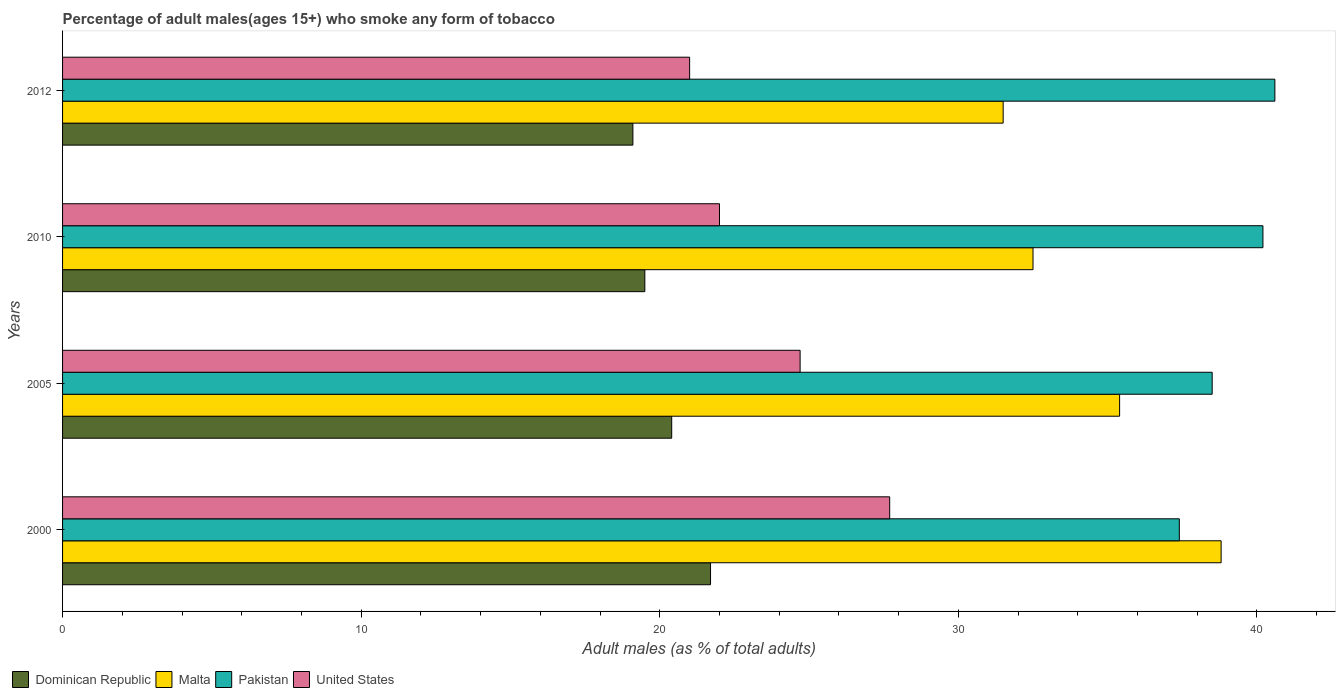How many different coloured bars are there?
Provide a short and direct response. 4. How many groups of bars are there?
Ensure brevity in your answer.  4. Are the number of bars per tick equal to the number of legend labels?
Offer a terse response. Yes. What is the percentage of adult males who smoke in Pakistan in 2012?
Provide a succinct answer. 40.6. Across all years, what is the maximum percentage of adult males who smoke in United States?
Offer a very short reply. 27.7. Across all years, what is the minimum percentage of adult males who smoke in United States?
Your response must be concise. 21. In which year was the percentage of adult males who smoke in Malta maximum?
Make the answer very short. 2000. In which year was the percentage of adult males who smoke in Pakistan minimum?
Offer a terse response. 2000. What is the total percentage of adult males who smoke in United States in the graph?
Offer a terse response. 95.4. What is the difference between the percentage of adult males who smoke in United States in 2000 and that in 2005?
Give a very brief answer. 3. What is the difference between the percentage of adult males who smoke in United States in 2010 and the percentage of adult males who smoke in Malta in 2005?
Your answer should be very brief. -13.4. What is the average percentage of adult males who smoke in Dominican Republic per year?
Make the answer very short. 20.17. In the year 2005, what is the difference between the percentage of adult males who smoke in Malta and percentage of adult males who smoke in Dominican Republic?
Offer a very short reply. 15. What is the ratio of the percentage of adult males who smoke in Dominican Republic in 2000 to that in 2005?
Keep it short and to the point. 1.06. Is the difference between the percentage of adult males who smoke in Malta in 2000 and 2010 greater than the difference between the percentage of adult males who smoke in Dominican Republic in 2000 and 2010?
Give a very brief answer. Yes. What is the difference between the highest and the second highest percentage of adult males who smoke in Malta?
Keep it short and to the point. 3.4. What is the difference between the highest and the lowest percentage of adult males who smoke in Malta?
Give a very brief answer. 7.3. In how many years, is the percentage of adult males who smoke in Malta greater than the average percentage of adult males who smoke in Malta taken over all years?
Provide a succinct answer. 2. Is it the case that in every year, the sum of the percentage of adult males who smoke in United States and percentage of adult males who smoke in Dominican Republic is greater than the sum of percentage of adult males who smoke in Malta and percentage of adult males who smoke in Pakistan?
Ensure brevity in your answer.  No. What does the 3rd bar from the top in 2010 represents?
Make the answer very short. Malta. What does the 4th bar from the bottom in 2010 represents?
Give a very brief answer. United States. How many bars are there?
Give a very brief answer. 16. Are all the bars in the graph horizontal?
Your answer should be very brief. Yes. Are the values on the major ticks of X-axis written in scientific E-notation?
Provide a short and direct response. No. Does the graph contain any zero values?
Your response must be concise. No. Where does the legend appear in the graph?
Offer a terse response. Bottom left. How many legend labels are there?
Make the answer very short. 4. How are the legend labels stacked?
Offer a terse response. Horizontal. What is the title of the graph?
Provide a succinct answer. Percentage of adult males(ages 15+) who smoke any form of tobacco. Does "Mauritius" appear as one of the legend labels in the graph?
Offer a very short reply. No. What is the label or title of the X-axis?
Your answer should be compact. Adult males (as % of total adults). What is the Adult males (as % of total adults) of Dominican Republic in 2000?
Offer a very short reply. 21.7. What is the Adult males (as % of total adults) of Malta in 2000?
Your answer should be very brief. 38.8. What is the Adult males (as % of total adults) in Pakistan in 2000?
Your response must be concise. 37.4. What is the Adult males (as % of total adults) of United States in 2000?
Give a very brief answer. 27.7. What is the Adult males (as % of total adults) of Dominican Republic in 2005?
Offer a very short reply. 20.4. What is the Adult males (as % of total adults) in Malta in 2005?
Offer a terse response. 35.4. What is the Adult males (as % of total adults) in Pakistan in 2005?
Offer a very short reply. 38.5. What is the Adult males (as % of total adults) in United States in 2005?
Keep it short and to the point. 24.7. What is the Adult males (as % of total adults) of Malta in 2010?
Ensure brevity in your answer.  32.5. What is the Adult males (as % of total adults) in Pakistan in 2010?
Offer a very short reply. 40.2. What is the Adult males (as % of total adults) of Dominican Republic in 2012?
Give a very brief answer. 19.1. What is the Adult males (as % of total adults) in Malta in 2012?
Your answer should be very brief. 31.5. What is the Adult males (as % of total adults) of Pakistan in 2012?
Provide a short and direct response. 40.6. What is the Adult males (as % of total adults) of United States in 2012?
Offer a very short reply. 21. Across all years, what is the maximum Adult males (as % of total adults) of Dominican Republic?
Ensure brevity in your answer.  21.7. Across all years, what is the maximum Adult males (as % of total adults) of Malta?
Your response must be concise. 38.8. Across all years, what is the maximum Adult males (as % of total adults) in Pakistan?
Your answer should be compact. 40.6. Across all years, what is the maximum Adult males (as % of total adults) of United States?
Keep it short and to the point. 27.7. Across all years, what is the minimum Adult males (as % of total adults) in Dominican Republic?
Offer a terse response. 19.1. Across all years, what is the minimum Adult males (as % of total adults) of Malta?
Your answer should be compact. 31.5. Across all years, what is the minimum Adult males (as % of total adults) of Pakistan?
Your answer should be very brief. 37.4. Across all years, what is the minimum Adult males (as % of total adults) of United States?
Provide a short and direct response. 21. What is the total Adult males (as % of total adults) of Dominican Republic in the graph?
Your answer should be very brief. 80.7. What is the total Adult males (as % of total adults) in Malta in the graph?
Your answer should be very brief. 138.2. What is the total Adult males (as % of total adults) of Pakistan in the graph?
Your answer should be very brief. 156.7. What is the total Adult males (as % of total adults) of United States in the graph?
Offer a terse response. 95.4. What is the difference between the Adult males (as % of total adults) of Malta in 2000 and that in 2005?
Your answer should be compact. 3.4. What is the difference between the Adult males (as % of total adults) in Pakistan in 2000 and that in 2005?
Give a very brief answer. -1.1. What is the difference between the Adult males (as % of total adults) in United States in 2000 and that in 2005?
Provide a short and direct response. 3. What is the difference between the Adult males (as % of total adults) of Dominican Republic in 2000 and that in 2010?
Your response must be concise. 2.2. What is the difference between the Adult males (as % of total adults) in Malta in 2000 and that in 2010?
Give a very brief answer. 6.3. What is the difference between the Adult males (as % of total adults) of Dominican Republic in 2000 and that in 2012?
Keep it short and to the point. 2.6. What is the difference between the Adult males (as % of total adults) of United States in 2000 and that in 2012?
Your answer should be very brief. 6.7. What is the difference between the Adult males (as % of total adults) in Malta in 2005 and that in 2010?
Provide a succinct answer. 2.9. What is the difference between the Adult males (as % of total adults) in United States in 2005 and that in 2010?
Provide a succinct answer. 2.7. What is the difference between the Adult males (as % of total adults) in Malta in 2010 and that in 2012?
Give a very brief answer. 1. What is the difference between the Adult males (as % of total adults) in Pakistan in 2010 and that in 2012?
Make the answer very short. -0.4. What is the difference between the Adult males (as % of total adults) of Dominican Republic in 2000 and the Adult males (as % of total adults) of Malta in 2005?
Offer a very short reply. -13.7. What is the difference between the Adult males (as % of total adults) in Dominican Republic in 2000 and the Adult males (as % of total adults) in Pakistan in 2005?
Offer a very short reply. -16.8. What is the difference between the Adult males (as % of total adults) in Dominican Republic in 2000 and the Adult males (as % of total adults) in United States in 2005?
Keep it short and to the point. -3. What is the difference between the Adult males (as % of total adults) of Dominican Republic in 2000 and the Adult males (as % of total adults) of Malta in 2010?
Offer a terse response. -10.8. What is the difference between the Adult males (as % of total adults) of Dominican Republic in 2000 and the Adult males (as % of total adults) of Pakistan in 2010?
Offer a very short reply. -18.5. What is the difference between the Adult males (as % of total adults) in Dominican Republic in 2000 and the Adult males (as % of total adults) in United States in 2010?
Offer a very short reply. -0.3. What is the difference between the Adult males (as % of total adults) in Malta in 2000 and the Adult males (as % of total adults) in United States in 2010?
Keep it short and to the point. 16.8. What is the difference between the Adult males (as % of total adults) in Dominican Republic in 2000 and the Adult males (as % of total adults) in Pakistan in 2012?
Keep it short and to the point. -18.9. What is the difference between the Adult males (as % of total adults) of Dominican Republic in 2000 and the Adult males (as % of total adults) of United States in 2012?
Provide a succinct answer. 0.7. What is the difference between the Adult males (as % of total adults) in Malta in 2000 and the Adult males (as % of total adults) in United States in 2012?
Keep it short and to the point. 17.8. What is the difference between the Adult males (as % of total adults) of Dominican Republic in 2005 and the Adult males (as % of total adults) of Malta in 2010?
Your response must be concise. -12.1. What is the difference between the Adult males (as % of total adults) of Dominican Republic in 2005 and the Adult males (as % of total adults) of Pakistan in 2010?
Ensure brevity in your answer.  -19.8. What is the difference between the Adult males (as % of total adults) in Dominican Republic in 2005 and the Adult males (as % of total adults) in United States in 2010?
Give a very brief answer. -1.6. What is the difference between the Adult males (as % of total adults) in Malta in 2005 and the Adult males (as % of total adults) in Pakistan in 2010?
Make the answer very short. -4.8. What is the difference between the Adult males (as % of total adults) in Pakistan in 2005 and the Adult males (as % of total adults) in United States in 2010?
Provide a succinct answer. 16.5. What is the difference between the Adult males (as % of total adults) in Dominican Republic in 2005 and the Adult males (as % of total adults) in Malta in 2012?
Provide a succinct answer. -11.1. What is the difference between the Adult males (as % of total adults) in Dominican Republic in 2005 and the Adult males (as % of total adults) in Pakistan in 2012?
Give a very brief answer. -20.2. What is the difference between the Adult males (as % of total adults) in Malta in 2005 and the Adult males (as % of total adults) in Pakistan in 2012?
Keep it short and to the point. -5.2. What is the difference between the Adult males (as % of total adults) in Malta in 2005 and the Adult males (as % of total adults) in United States in 2012?
Provide a short and direct response. 14.4. What is the difference between the Adult males (as % of total adults) of Pakistan in 2005 and the Adult males (as % of total adults) of United States in 2012?
Ensure brevity in your answer.  17.5. What is the difference between the Adult males (as % of total adults) in Dominican Republic in 2010 and the Adult males (as % of total adults) in Malta in 2012?
Provide a succinct answer. -12. What is the difference between the Adult males (as % of total adults) of Dominican Republic in 2010 and the Adult males (as % of total adults) of Pakistan in 2012?
Your answer should be very brief. -21.1. What is the difference between the Adult males (as % of total adults) of Dominican Republic in 2010 and the Adult males (as % of total adults) of United States in 2012?
Your answer should be compact. -1.5. What is the average Adult males (as % of total adults) of Dominican Republic per year?
Give a very brief answer. 20.18. What is the average Adult males (as % of total adults) in Malta per year?
Ensure brevity in your answer.  34.55. What is the average Adult males (as % of total adults) of Pakistan per year?
Ensure brevity in your answer.  39.17. What is the average Adult males (as % of total adults) of United States per year?
Give a very brief answer. 23.85. In the year 2000, what is the difference between the Adult males (as % of total adults) in Dominican Republic and Adult males (as % of total adults) in Malta?
Your response must be concise. -17.1. In the year 2000, what is the difference between the Adult males (as % of total adults) in Dominican Republic and Adult males (as % of total adults) in Pakistan?
Offer a terse response. -15.7. In the year 2000, what is the difference between the Adult males (as % of total adults) in Malta and Adult males (as % of total adults) in United States?
Your response must be concise. 11.1. In the year 2000, what is the difference between the Adult males (as % of total adults) in Pakistan and Adult males (as % of total adults) in United States?
Your answer should be very brief. 9.7. In the year 2005, what is the difference between the Adult males (as % of total adults) in Dominican Republic and Adult males (as % of total adults) in Pakistan?
Offer a very short reply. -18.1. In the year 2005, what is the difference between the Adult males (as % of total adults) in Malta and Adult males (as % of total adults) in Pakistan?
Make the answer very short. -3.1. In the year 2005, what is the difference between the Adult males (as % of total adults) of Malta and Adult males (as % of total adults) of United States?
Ensure brevity in your answer.  10.7. In the year 2005, what is the difference between the Adult males (as % of total adults) in Pakistan and Adult males (as % of total adults) in United States?
Give a very brief answer. 13.8. In the year 2010, what is the difference between the Adult males (as % of total adults) of Dominican Republic and Adult males (as % of total adults) of Malta?
Give a very brief answer. -13. In the year 2010, what is the difference between the Adult males (as % of total adults) in Dominican Republic and Adult males (as % of total adults) in Pakistan?
Your answer should be compact. -20.7. In the year 2010, what is the difference between the Adult males (as % of total adults) in Malta and Adult males (as % of total adults) in Pakistan?
Make the answer very short. -7.7. In the year 2010, what is the difference between the Adult males (as % of total adults) in Malta and Adult males (as % of total adults) in United States?
Your answer should be compact. 10.5. In the year 2010, what is the difference between the Adult males (as % of total adults) of Pakistan and Adult males (as % of total adults) of United States?
Provide a short and direct response. 18.2. In the year 2012, what is the difference between the Adult males (as % of total adults) in Dominican Republic and Adult males (as % of total adults) in Pakistan?
Your answer should be compact. -21.5. In the year 2012, what is the difference between the Adult males (as % of total adults) of Malta and Adult males (as % of total adults) of Pakistan?
Provide a short and direct response. -9.1. In the year 2012, what is the difference between the Adult males (as % of total adults) in Malta and Adult males (as % of total adults) in United States?
Your answer should be compact. 10.5. In the year 2012, what is the difference between the Adult males (as % of total adults) in Pakistan and Adult males (as % of total adults) in United States?
Provide a succinct answer. 19.6. What is the ratio of the Adult males (as % of total adults) in Dominican Republic in 2000 to that in 2005?
Provide a succinct answer. 1.06. What is the ratio of the Adult males (as % of total adults) in Malta in 2000 to that in 2005?
Keep it short and to the point. 1.1. What is the ratio of the Adult males (as % of total adults) in Pakistan in 2000 to that in 2005?
Give a very brief answer. 0.97. What is the ratio of the Adult males (as % of total adults) of United States in 2000 to that in 2005?
Provide a short and direct response. 1.12. What is the ratio of the Adult males (as % of total adults) in Dominican Republic in 2000 to that in 2010?
Ensure brevity in your answer.  1.11. What is the ratio of the Adult males (as % of total adults) in Malta in 2000 to that in 2010?
Offer a terse response. 1.19. What is the ratio of the Adult males (as % of total adults) in Pakistan in 2000 to that in 2010?
Give a very brief answer. 0.93. What is the ratio of the Adult males (as % of total adults) in United States in 2000 to that in 2010?
Your answer should be compact. 1.26. What is the ratio of the Adult males (as % of total adults) in Dominican Republic in 2000 to that in 2012?
Your answer should be very brief. 1.14. What is the ratio of the Adult males (as % of total adults) of Malta in 2000 to that in 2012?
Keep it short and to the point. 1.23. What is the ratio of the Adult males (as % of total adults) in Pakistan in 2000 to that in 2012?
Your answer should be very brief. 0.92. What is the ratio of the Adult males (as % of total adults) in United States in 2000 to that in 2012?
Your answer should be compact. 1.32. What is the ratio of the Adult males (as % of total adults) in Dominican Republic in 2005 to that in 2010?
Ensure brevity in your answer.  1.05. What is the ratio of the Adult males (as % of total adults) of Malta in 2005 to that in 2010?
Provide a succinct answer. 1.09. What is the ratio of the Adult males (as % of total adults) of Pakistan in 2005 to that in 2010?
Keep it short and to the point. 0.96. What is the ratio of the Adult males (as % of total adults) of United States in 2005 to that in 2010?
Make the answer very short. 1.12. What is the ratio of the Adult males (as % of total adults) of Dominican Republic in 2005 to that in 2012?
Provide a succinct answer. 1.07. What is the ratio of the Adult males (as % of total adults) in Malta in 2005 to that in 2012?
Your answer should be compact. 1.12. What is the ratio of the Adult males (as % of total adults) in Pakistan in 2005 to that in 2012?
Offer a terse response. 0.95. What is the ratio of the Adult males (as % of total adults) of United States in 2005 to that in 2012?
Make the answer very short. 1.18. What is the ratio of the Adult males (as % of total adults) of Dominican Republic in 2010 to that in 2012?
Your answer should be compact. 1.02. What is the ratio of the Adult males (as % of total adults) in Malta in 2010 to that in 2012?
Provide a succinct answer. 1.03. What is the ratio of the Adult males (as % of total adults) in Pakistan in 2010 to that in 2012?
Make the answer very short. 0.99. What is the ratio of the Adult males (as % of total adults) in United States in 2010 to that in 2012?
Offer a very short reply. 1.05. What is the difference between the highest and the second highest Adult males (as % of total adults) of Dominican Republic?
Ensure brevity in your answer.  1.3. What is the difference between the highest and the second highest Adult males (as % of total adults) in United States?
Your answer should be compact. 3. What is the difference between the highest and the lowest Adult males (as % of total adults) of Dominican Republic?
Keep it short and to the point. 2.6. What is the difference between the highest and the lowest Adult males (as % of total adults) in United States?
Your answer should be very brief. 6.7. 